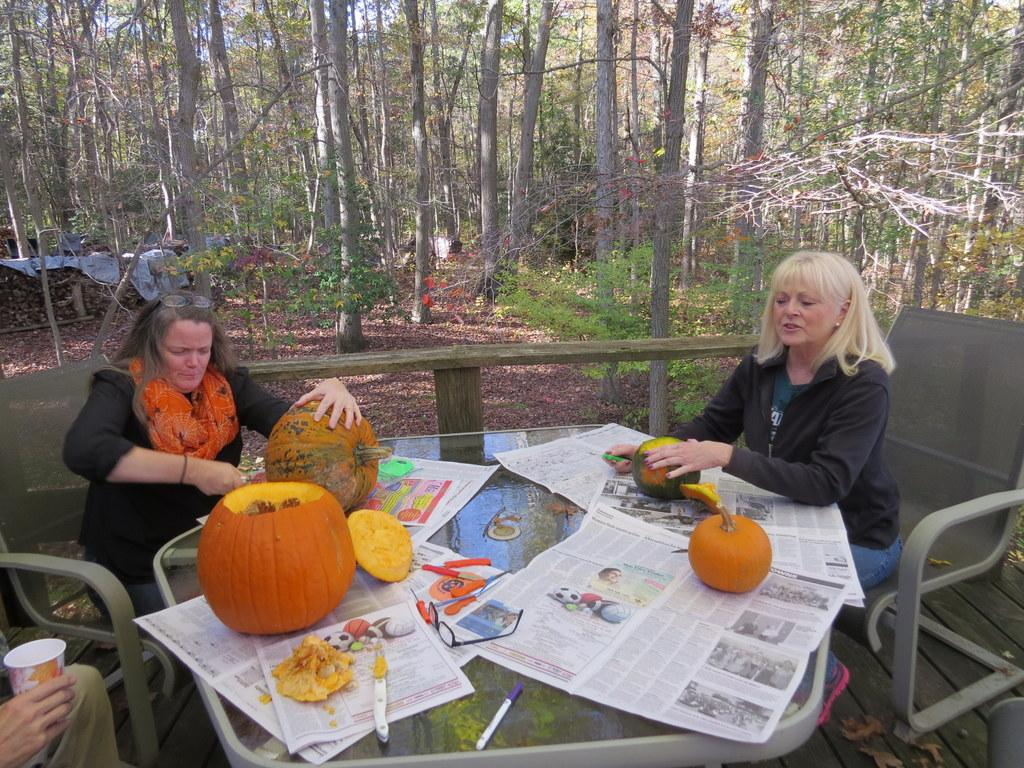What type of vegetation can be seen in the image? There are trees in the image. How many people are sitting in the image? There are three people sitting on chairs in the image. What is on the table in the image? There are papers, spectacles, a pen, a knife, and a pumpkin on the table. What type of throat medicine is on the table in the image? There is no throat medicine present in the image. Is the man sitting on the left chair in the image regretting something? There is no indication of regret or any man in the image; it only shows three people sitting on chairs. 